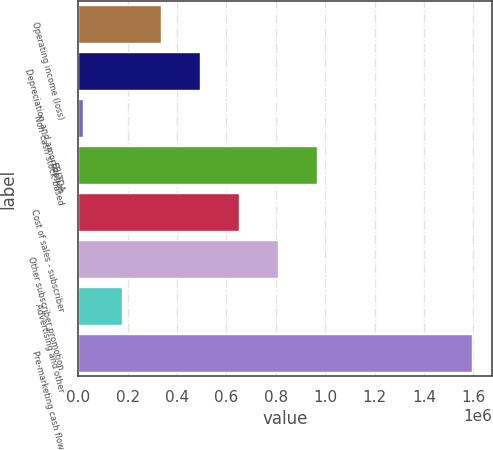Convert chart to OTSL. <chart><loc_0><loc_0><loc_500><loc_500><bar_chart><fcel>Operating income (loss)<fcel>Depreciation and amortization<fcel>Non-cash stock-based<fcel>EBITDA<fcel>Cost of sales - subscriber<fcel>Other subscriber promotion<fcel>Advertising and other<fcel>Pre-marketing cash flow<nl><fcel>335239<fcel>492772<fcel>20173<fcel>965370<fcel>650305<fcel>807838<fcel>177706<fcel>1.5955e+06<nl></chart> 